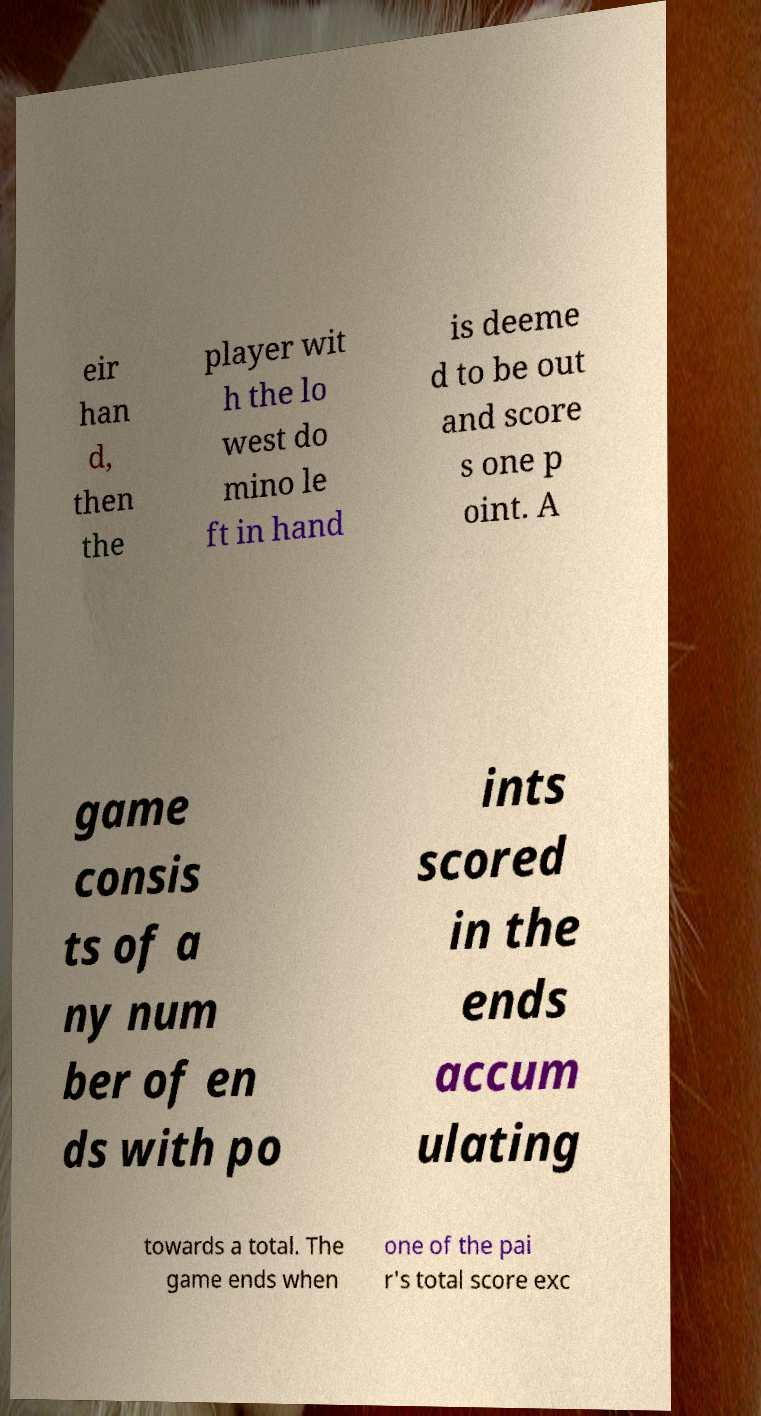Could you assist in decoding the text presented in this image and type it out clearly? eir han d, then the player wit h the lo west do mino le ft in hand is deeme d to be out and score s one p oint. A game consis ts of a ny num ber of en ds with po ints scored in the ends accum ulating towards a total. The game ends when one of the pai r's total score exc 